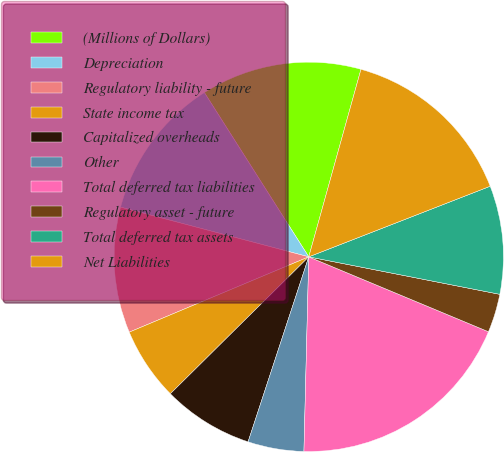Convert chart to OTSL. <chart><loc_0><loc_0><loc_500><loc_500><pie_chart><fcel>(Millions of Dollars)<fcel>Depreciation<fcel>Regulatory liability - future<fcel>State income tax<fcel>Capitalized overheads<fcel>Other<fcel>Total deferred tax liabilities<fcel>Regulatory asset - future<fcel>Total deferred tax assets<fcel>Net Liabilities<nl><fcel>13.33%<fcel>11.88%<fcel>10.43%<fcel>6.09%<fcel>7.54%<fcel>4.65%<fcel>19.11%<fcel>3.2%<fcel>8.99%<fcel>14.77%<nl></chart> 